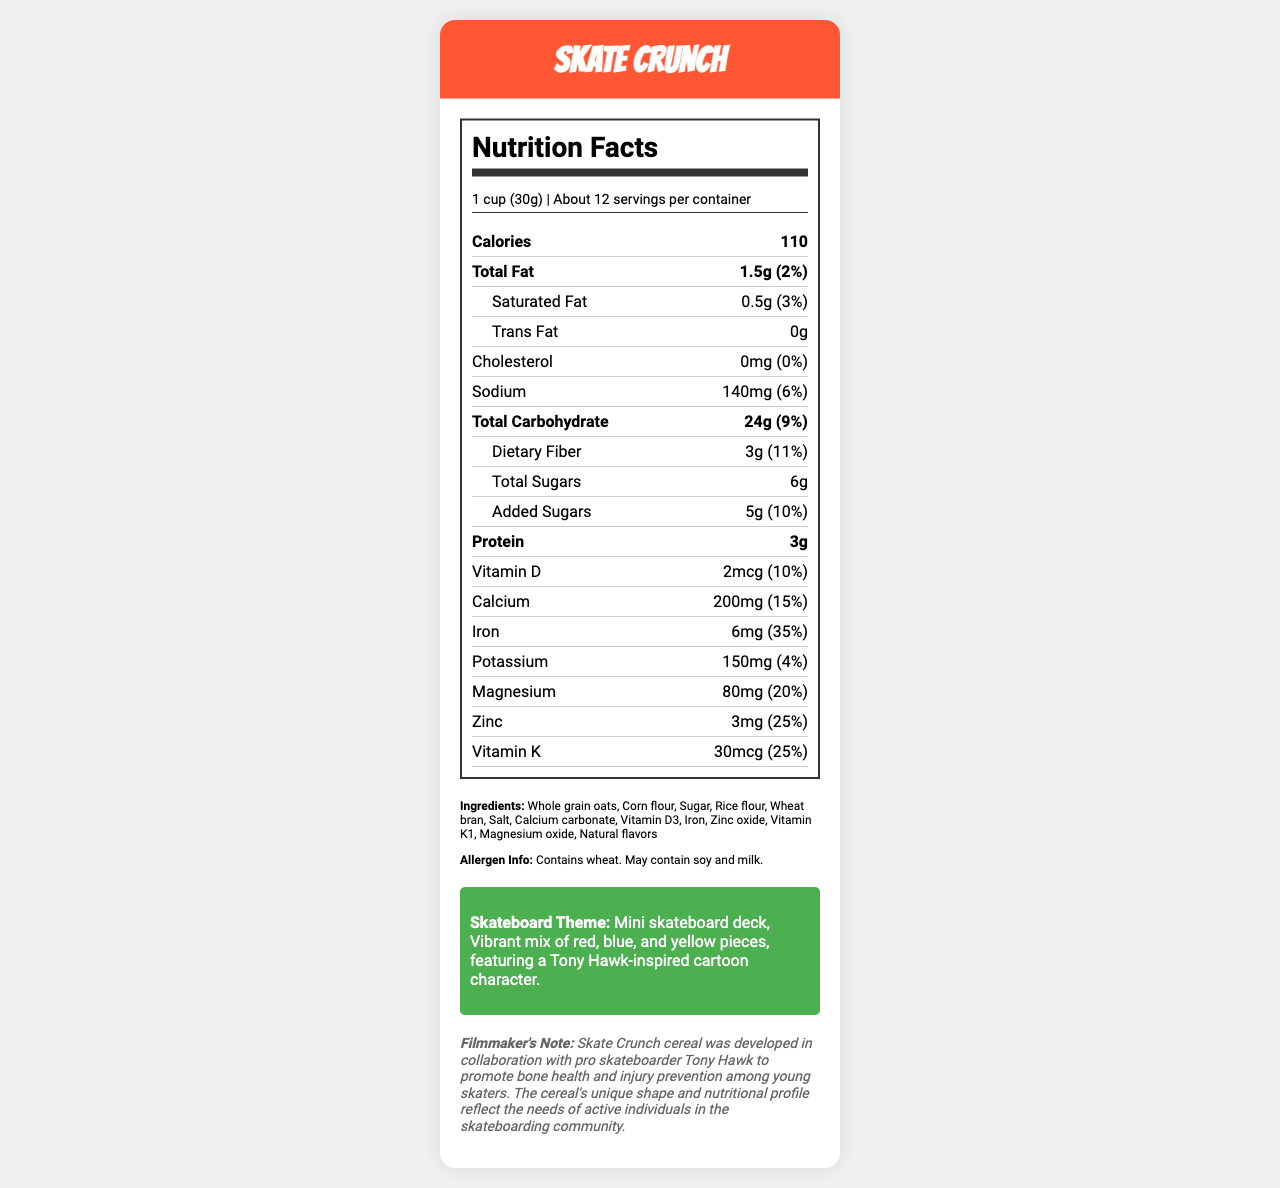what is the serving size? The serving size is listed at the beginning of the Nutrition Facts section.
Answer: 1 cup (30g) how many calories are in one serving of Skate Crunch? The calorie count is displayed prominently right after the serving size information.
Answer: 110 what percentage of the daily value for calcium does one serving provide? The daily value percentage for calcium is shown next to the calcium content in the Nutrition Facts section.
Answer: 15% what is the shape of the Skate Crunch cereal pieces? The shape of the cereal pieces is detailed in the Skateboard Theme section.
Answer: Mini skateboard deck list three vitamins or minerals in Skate Crunch and their daily values in percentage. Vitamin D, Magnesium, and Zinc along with their daily values are listed individually in the Nutrition Facts section.
Answer: Vitamin D (10%), Magnesium (20%), Zinc (25%) which ingredient might cause allergies for some people? The allergen information lists wheat as a potential allergen.
Answer: Wheat how much protein is in a serving of Skate Crunch? The amount of protein per serving is listed in the Nutrition Facts section.
Answer: 3g how many grams of dietary fiber are in a serving? The dietary fiber content is listed under Total Carbohydrate in the Nutrition Facts section.
Answer: 3g Total Fat is to Saturated Fat as Total Carbohydrate is to which sub-item? Total Fat has a sub-item Saturated Fat, while Total Carbohydrate has a sub-item Dietary Fiber.
Answer: Dietary Fiber which vitamin has the highest daily value percentage in the cereal? A. Vitamin D B. Calcium C. Iron D. Vitamin K Iron has the highest daily value percentage at 35%, compared to other vitamins listed.
Answer: C. Iron which of the following is NOT an ingredient in Skate Crunch? A. Whole grain oats B. Corn flour C. Chocolate D. Rice flour The ingredient list does not mention chocolate.
Answer: C. Chocolate does the product contain any cholesterol? The cholesterol content is listed as 0mg with a daily value of 0%.
Answer: No is Skate Crunch suitable for someone who is lactose intolerant? The allergen info states it may contain soy and milk, so it’s unclear if it’s suitable for someone with lactose intolerance.
Answer: Not enough information describe the main theme and appeal of the Skate Crunch cereal. The document highlights that Skate Crunch is designed with the nutritional needs of skaters in mind and is visually appealing with its skateboard theme and colorful pieces.
Answer: Skate Crunch is a skateboard-themed cereal designed to promote bone health and injury prevention among skaters, featuring a vibrant mix of red, blue, and yellow mini skateboard deck-shaped pieces. The product was developed in collaboration with pro skateboarder Tony Hawk to meet the nutritional needs of young, active individuals. 